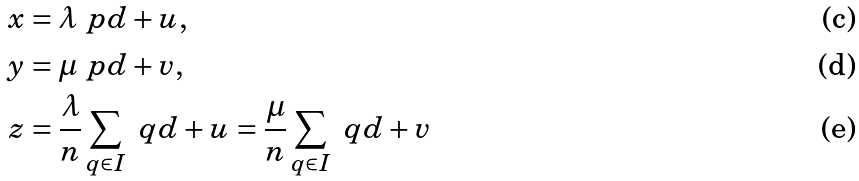<formula> <loc_0><loc_0><loc_500><loc_500>x & = \lambda \ p d + u , \\ y & = \mu \ p d + v , \\ z & = \frac { \lambda } { n } \sum _ { q \in I } \ q d + u = \frac { \mu } { n } \sum _ { q \in I } \ q d + v</formula> 